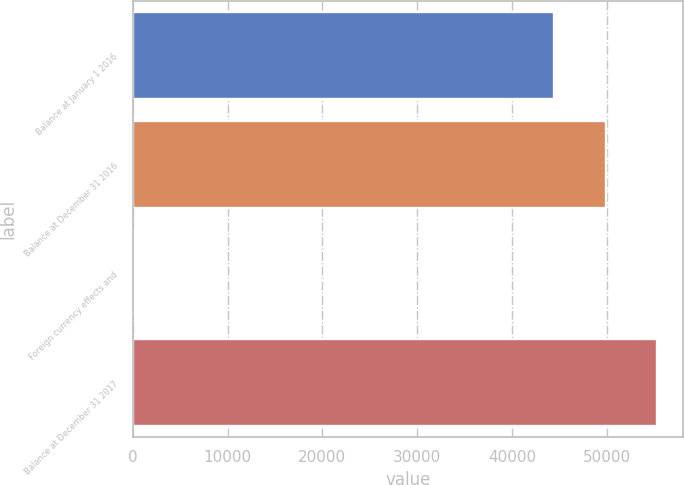Convert chart to OTSL. <chart><loc_0><loc_0><loc_500><loc_500><bar_chart><fcel>Balance at January 1 2016<fcel>Balance at December 31 2016<fcel>Foreign currency effects and<fcel>Balance at December 31 2017<nl><fcel>44453<fcel>49895.8<fcel>128<fcel>55338.6<nl></chart> 